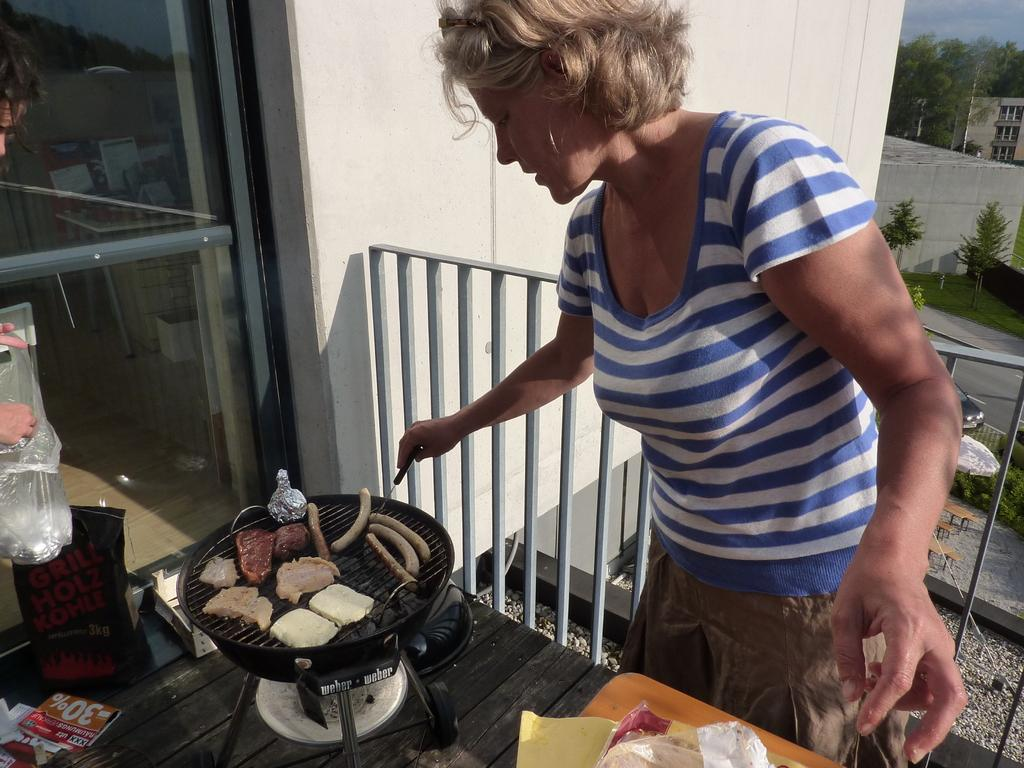Provide a one-sentence caption for the provided image. A woman cooks the sausages that she got 30% extra free on. 